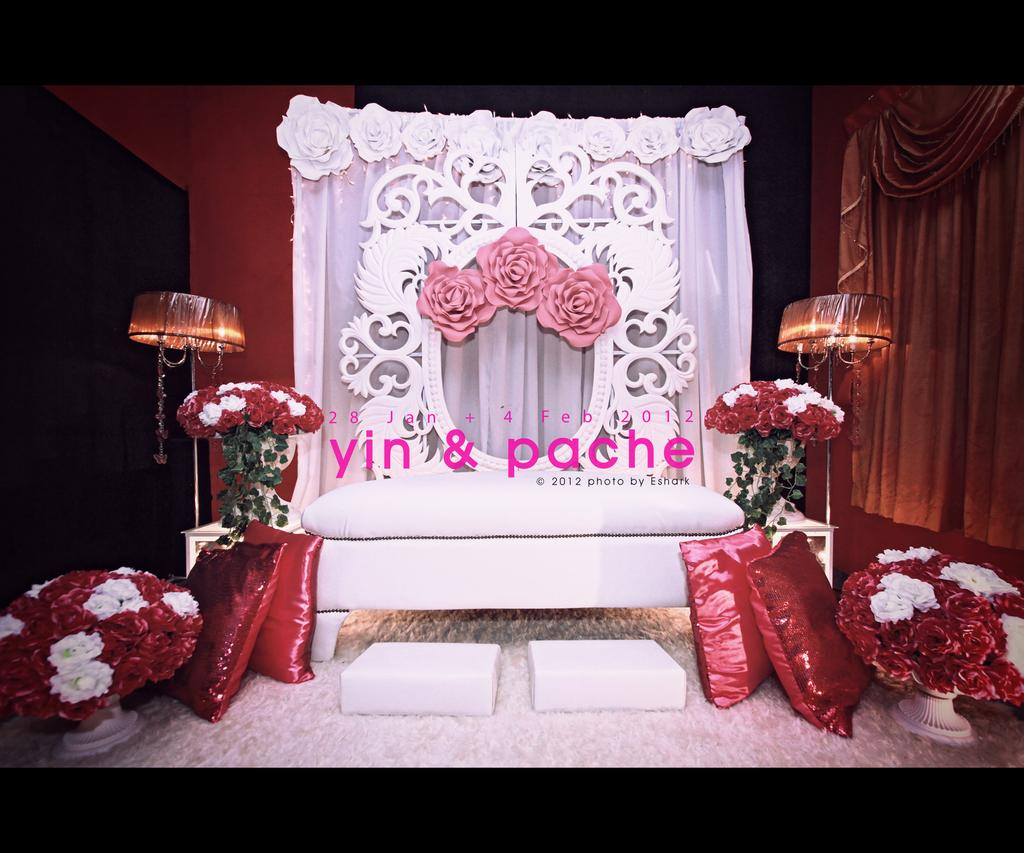What type of seating or comfort items are present in the image? There are cushions in the image. What type of decorative items are present in the image? There are flower pots in the image. Where are the cushions and flower pots located in the image? The cushions and flower pots are at the bottom of the image. What type of furniture is present in the image? There is a bed in the image. How many lamps are present in the image? There are two lamps in the image. Where are the bed and lamps located in the image? The bed and lamps are in the middle of the image. What can be seen in the background of the image? There is a curtain in the background of the image. How many rabbits are hopping on the bridge in the image? There is no bridge or rabbits present in the image. What type of cover is used for the bed in the image? The provided facts do not mention a cover for the bed, so we cannot determine its type from the image. 